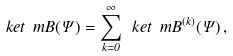Convert formula to latex. <formula><loc_0><loc_0><loc_500><loc_500>\ k e t { \ m B ( \Psi ) } = \sum _ { k = 0 } ^ { \infty } \ k e t { \ m B ^ { ( k ) } ( \Psi ) } \, ,</formula> 